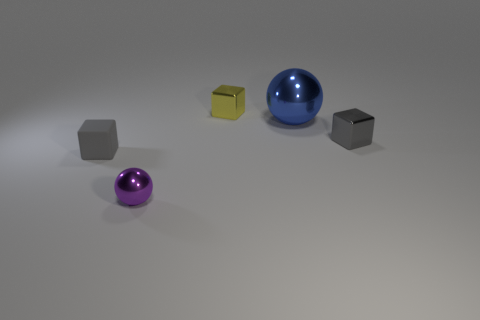Are there an equal number of tiny metallic blocks that are in front of the yellow object and big blue metallic spheres?
Provide a short and direct response. Yes. Do the thing that is on the left side of the purple shiny object and the tiny purple metallic sphere have the same size?
Your answer should be compact. Yes. What color is the shiny ball that is the same size as the gray matte thing?
Provide a succinct answer. Purple. There is a cube in front of the gray thing on the right side of the tiny purple sphere; are there any yellow cubes that are right of it?
Offer a very short reply. Yes. There is a gray block that is on the right side of the small purple metallic sphere; what is it made of?
Ensure brevity in your answer.  Metal. Does the big blue shiny object have the same shape as the small thing that is right of the yellow object?
Your response must be concise. No. Is the number of tiny gray metallic blocks in front of the gray metal block the same as the number of tiny purple objects behind the gray matte cube?
Your answer should be compact. Yes. What number of other things are there of the same material as the tiny purple sphere
Provide a short and direct response. 3. What number of matte things are blue cylinders or blue objects?
Your answer should be compact. 0. There is a small metallic object that is behind the gray metallic thing; does it have the same shape as the large blue metallic thing?
Your response must be concise. No. 